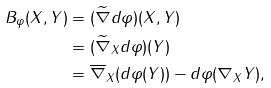Convert formula to latex. <formula><loc_0><loc_0><loc_500><loc_500>B _ { \varphi } ( X , Y ) & = ( \widetilde { \nabla } d \varphi ) ( X , Y ) \\ & = ( \widetilde { \nabla } _ { X } d \varphi ) ( Y ) \\ & = \overline { \nabla } _ { X } ( d \varphi ( Y ) ) - d \varphi ( \nabla _ { X } Y ) ,</formula> 